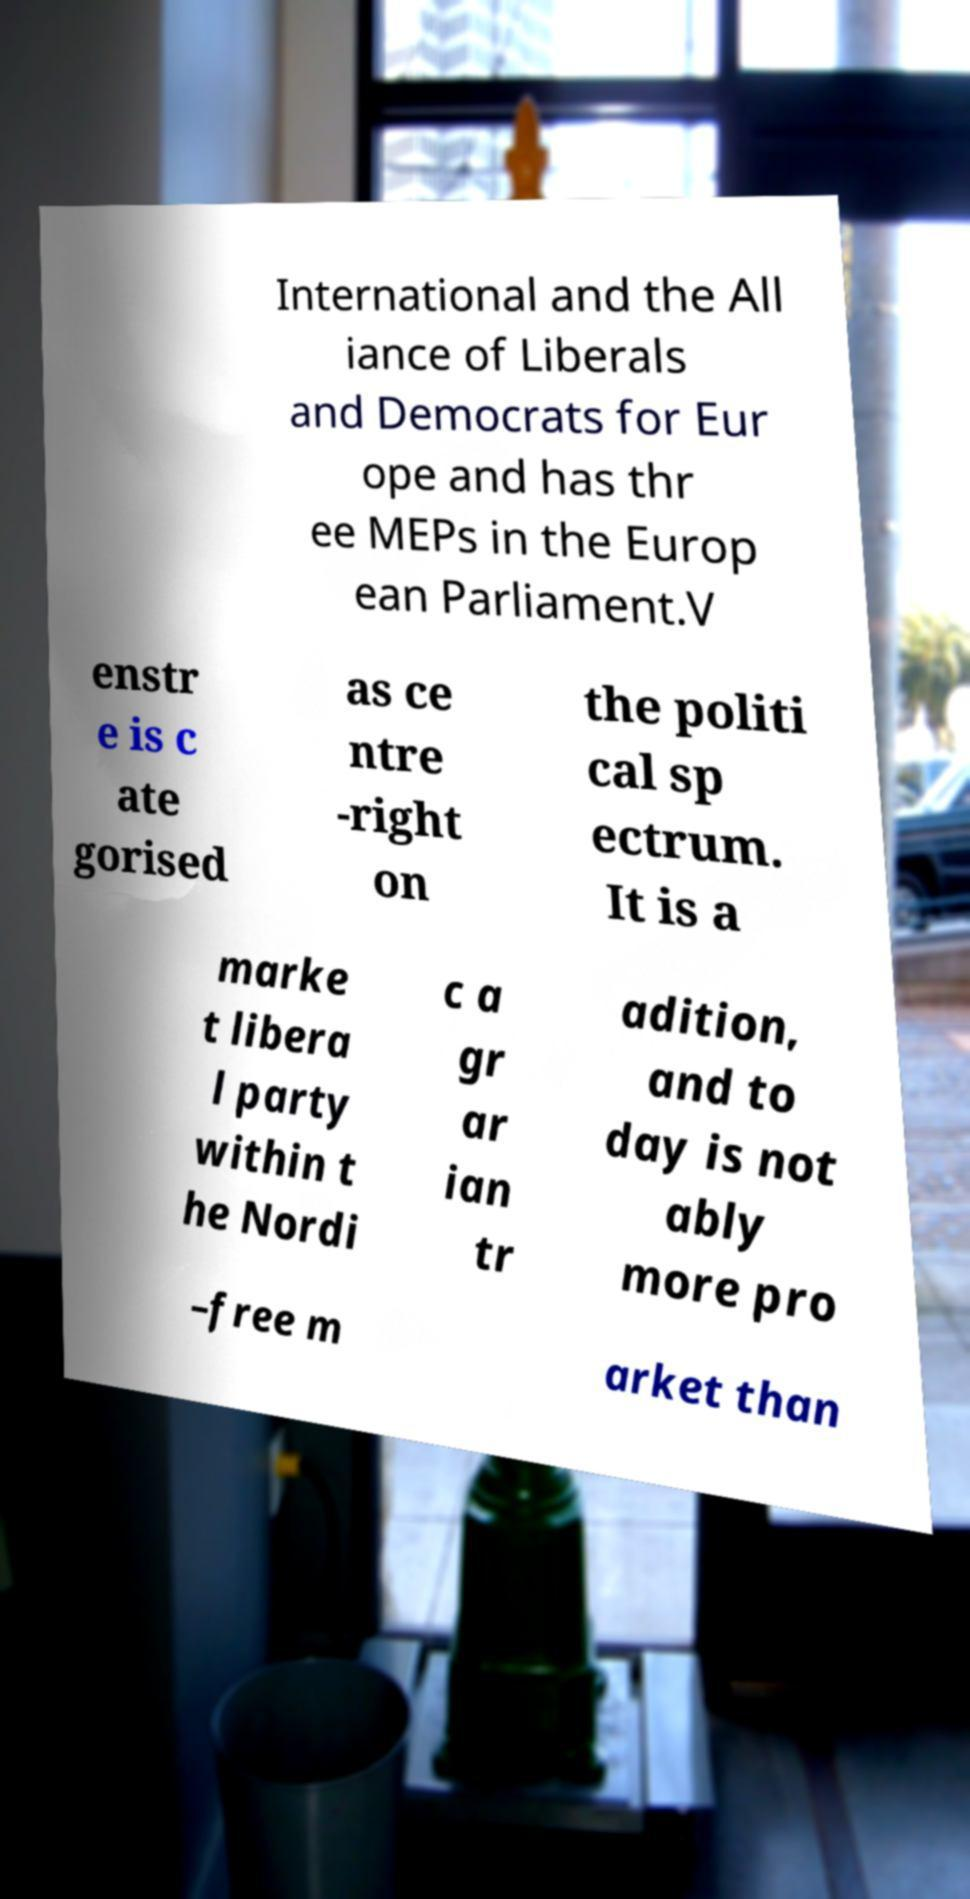Could you extract and type out the text from this image? International and the All iance of Liberals and Democrats for Eur ope and has thr ee MEPs in the Europ ean Parliament.V enstr e is c ate gorised as ce ntre -right on the politi cal sp ectrum. It is a marke t libera l party within t he Nordi c a gr ar ian tr adition, and to day is not ably more pro –free m arket than 